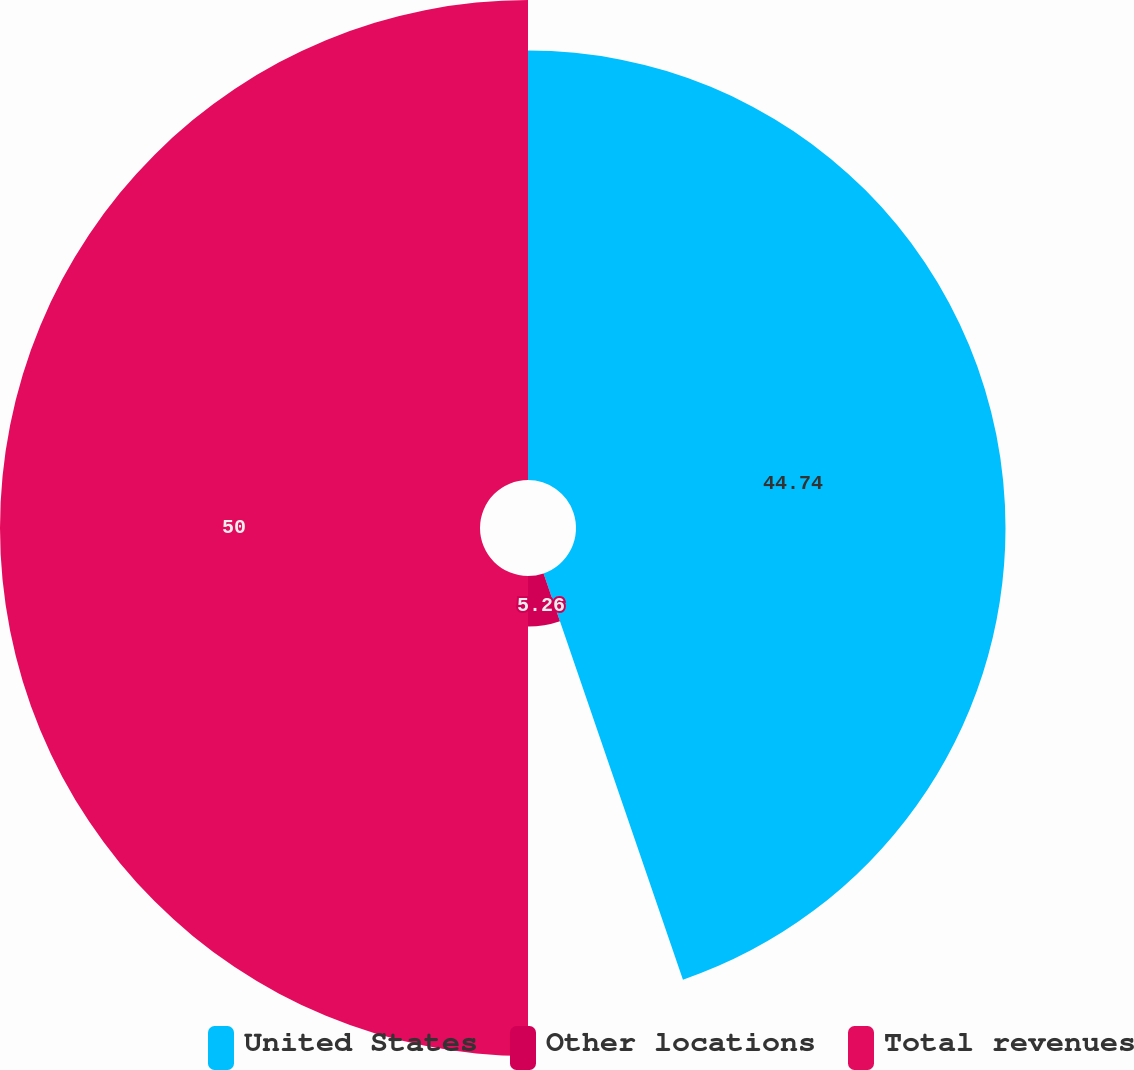<chart> <loc_0><loc_0><loc_500><loc_500><pie_chart><fcel>United States<fcel>Other locations<fcel>Total revenues<nl><fcel>44.74%<fcel>5.26%<fcel>50.0%<nl></chart> 